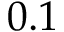<formula> <loc_0><loc_0><loc_500><loc_500>0 . 1</formula> 